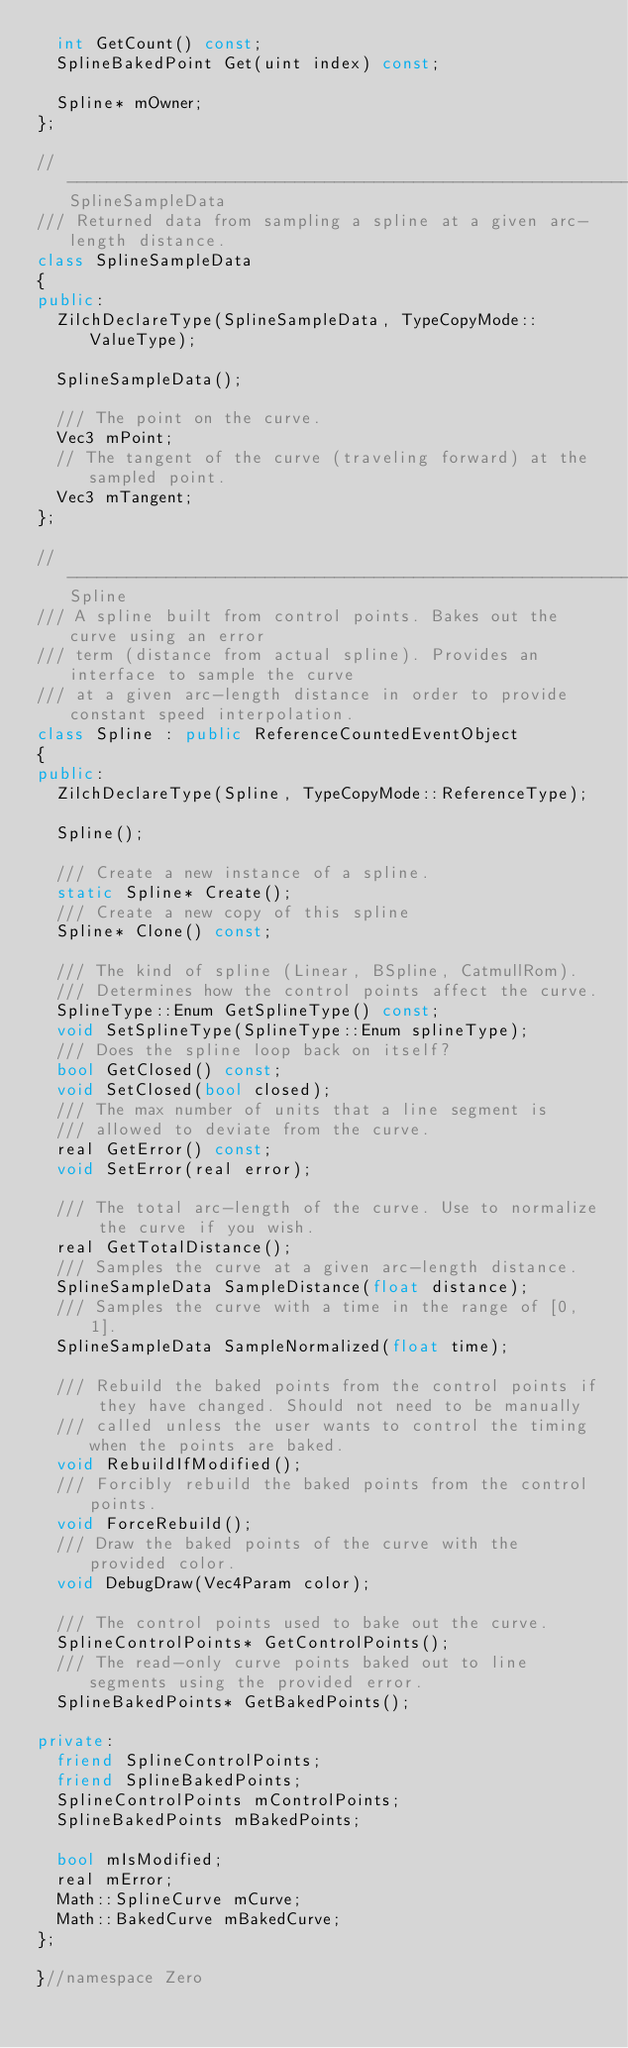<code> <loc_0><loc_0><loc_500><loc_500><_C++_>  int GetCount() const;
  SplineBakedPoint Get(uint index) const;

  Spline* mOwner;
};

//-------------------------------------------------------------------SplineSampleData
/// Returned data from sampling a spline at a given arc-length distance.
class SplineSampleData
{
public:
  ZilchDeclareType(SplineSampleData, TypeCopyMode::ValueType);

  SplineSampleData();

  /// The point on the curve.
  Vec3 mPoint;
  // The tangent of the curve (traveling forward) at the sampled point.
  Vec3 mTangent;
};

//-------------------------------------------------------------------Spline
/// A spline built from control points. Bakes out the curve using an error
/// term (distance from actual spline). Provides an interface to sample the curve
/// at a given arc-length distance in order to provide constant speed interpolation.
class Spline : public ReferenceCountedEventObject
{
public:
  ZilchDeclareType(Spline, TypeCopyMode::ReferenceType);

  Spline();

  /// Create a new instance of a spline.
  static Spline* Create();
  /// Create a new copy of this spline
  Spline* Clone() const;

  /// The kind of spline (Linear, BSpline, CatmullRom).
  /// Determines how the control points affect the curve.
  SplineType::Enum GetSplineType() const;
  void SetSplineType(SplineType::Enum splineType);
  /// Does the spline loop back on itself?
  bool GetClosed() const;
  void SetClosed(bool closed);
  /// The max number of units that a line segment is
  /// allowed to deviate from the curve.
  real GetError() const;
  void SetError(real error);

  /// The total arc-length of the curve. Use to normalize the curve if you wish.
  real GetTotalDistance();
  /// Samples the curve at a given arc-length distance.
  SplineSampleData SampleDistance(float distance);
  /// Samples the curve with a time in the range of [0, 1].
  SplineSampleData SampleNormalized(float time);

  /// Rebuild the baked points from the control points if they have changed. Should not need to be manually
  /// called unless the user wants to control the timing when the points are baked.
  void RebuildIfModified();
  /// Forcibly rebuild the baked points from the control points.
  void ForceRebuild();
  /// Draw the baked points of the curve with the provided color.
  void DebugDraw(Vec4Param color);

  /// The control points used to bake out the curve.
  SplineControlPoints* GetControlPoints();
  /// The read-only curve points baked out to line segments using the provided error.
  SplineBakedPoints* GetBakedPoints();

private:
  friend SplineControlPoints;
  friend SplineBakedPoints;
  SplineControlPoints mControlPoints;
  SplineBakedPoints mBakedPoints;

  bool mIsModified;
  real mError;
  Math::SplineCurve mCurve;
  Math::BakedCurve mBakedCurve;
};

}//namespace Zero
</code> 